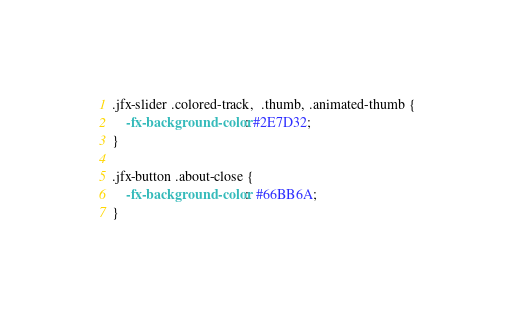Convert code to text. <code><loc_0><loc_0><loc_500><loc_500><_CSS_>.jfx-slider .colored-track,  .thumb, .animated-thumb {
	-fx-background-color: #2E7D32;
}

.jfx-button .about-close {
	-fx-background-color:  #66BB6A;
}</code> 